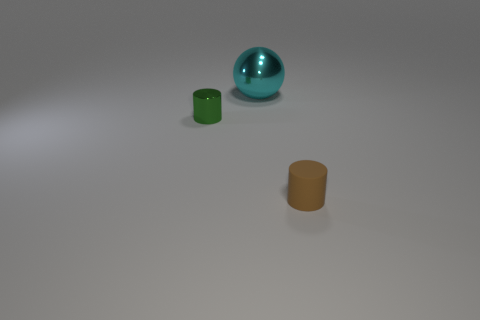Is the shape of the small metallic thing the same as the small rubber thing? The small metallic object appears to be a reflective sphere, while the small rubber item seems to be a cylindrical cap. While both objects are small and share a symmetrical form, their exact shapes are not the same; one is spherical and the other is cylindrical. 